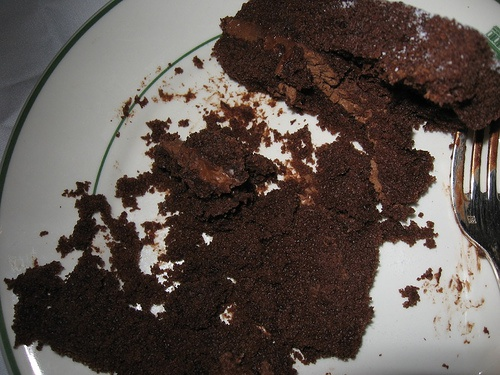Describe the objects in this image and their specific colors. I can see cake in black, maroon, darkgray, and gray tones and fork in black, gray, maroon, and lightgray tones in this image. 